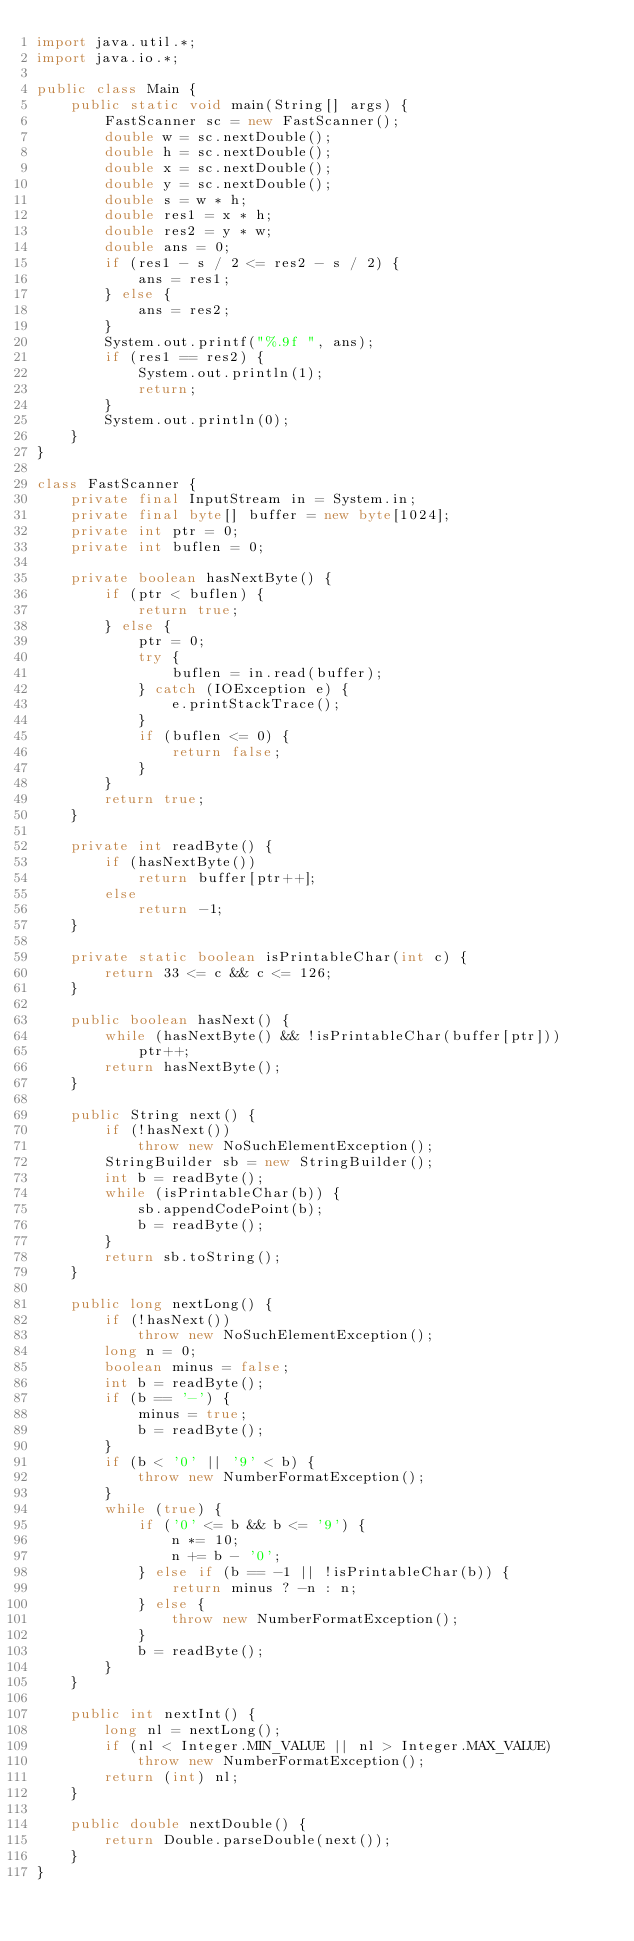<code> <loc_0><loc_0><loc_500><loc_500><_Java_>import java.util.*;
import java.io.*;

public class Main {
    public static void main(String[] args) {
        FastScanner sc = new FastScanner();
        double w = sc.nextDouble();
        double h = sc.nextDouble();
        double x = sc.nextDouble();
        double y = sc.nextDouble();
        double s = w * h;
        double res1 = x * h;
        double res2 = y * w;
        double ans = 0;
        if (res1 - s / 2 <= res2 - s / 2) {
            ans = res1;
        } else {
            ans = res2;
        }
        System.out.printf("%.9f ", ans);
        if (res1 == res2) {
            System.out.println(1);
            return;
        }
        System.out.println(0);
    }
}

class FastScanner {
    private final InputStream in = System.in;
    private final byte[] buffer = new byte[1024];
    private int ptr = 0;
    private int buflen = 0;

    private boolean hasNextByte() {
        if (ptr < buflen) {
            return true;
        } else {
            ptr = 0;
            try {
                buflen = in.read(buffer);
            } catch (IOException e) {
                e.printStackTrace();
            }
            if (buflen <= 0) {
                return false;
            }
        }
        return true;
    }

    private int readByte() {
        if (hasNextByte())
            return buffer[ptr++];
        else
            return -1;
    }

    private static boolean isPrintableChar(int c) {
        return 33 <= c && c <= 126;
    }

    public boolean hasNext() {
        while (hasNextByte() && !isPrintableChar(buffer[ptr]))
            ptr++;
        return hasNextByte();
    }

    public String next() {
        if (!hasNext())
            throw new NoSuchElementException();
        StringBuilder sb = new StringBuilder();
        int b = readByte();
        while (isPrintableChar(b)) {
            sb.appendCodePoint(b);
            b = readByte();
        }
        return sb.toString();
    }

    public long nextLong() {
        if (!hasNext())
            throw new NoSuchElementException();
        long n = 0;
        boolean minus = false;
        int b = readByte();
        if (b == '-') {
            minus = true;
            b = readByte();
        }
        if (b < '0' || '9' < b) {
            throw new NumberFormatException();
        }
        while (true) {
            if ('0' <= b && b <= '9') {
                n *= 10;
                n += b - '0';
            } else if (b == -1 || !isPrintableChar(b)) {
                return minus ? -n : n;
            } else {
                throw new NumberFormatException();
            }
            b = readByte();
        }
    }

    public int nextInt() {
        long nl = nextLong();
        if (nl < Integer.MIN_VALUE || nl > Integer.MAX_VALUE)
            throw new NumberFormatException();
        return (int) nl;
    }

    public double nextDouble() {
        return Double.parseDouble(next());
    }
}
</code> 